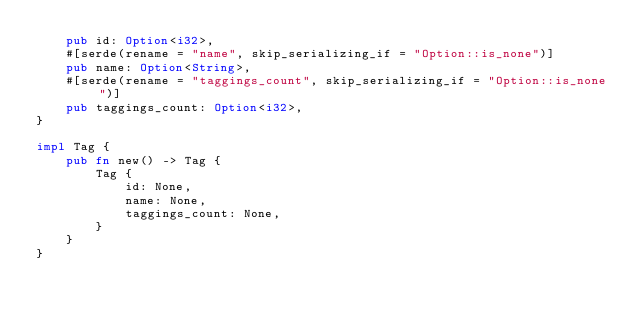Convert code to text. <code><loc_0><loc_0><loc_500><loc_500><_Rust_>    pub id: Option<i32>,
    #[serde(rename = "name", skip_serializing_if = "Option::is_none")]
    pub name: Option<String>,
    #[serde(rename = "taggings_count", skip_serializing_if = "Option::is_none")]
    pub taggings_count: Option<i32>,
}

impl Tag {
    pub fn new() -> Tag {
        Tag {
            id: None,
            name: None,
            taggings_count: None,
        }
    }
}


</code> 